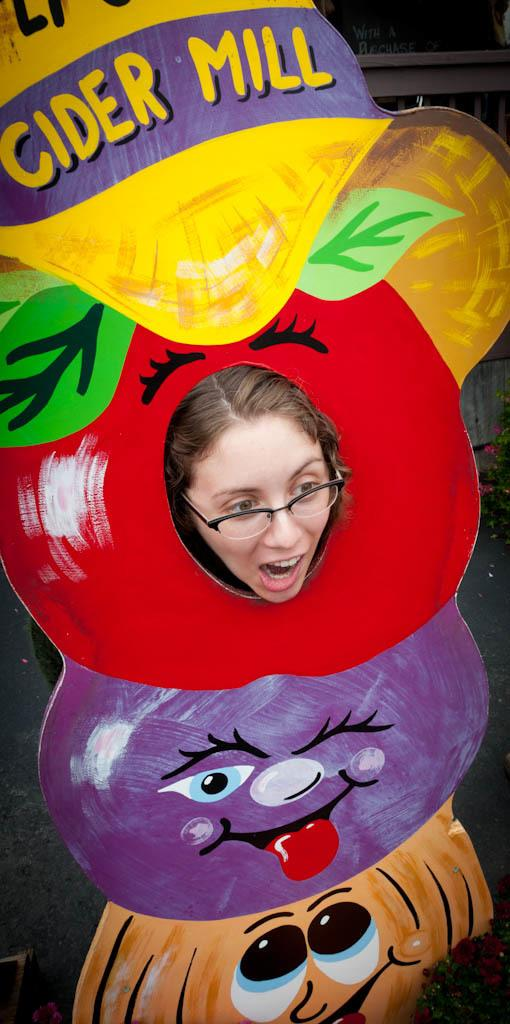What is the main subject of the image? The main subject of the image is a woman's head. What can be seen on the woman's face? The woman is wearing spectacles. What is the appearance of the board in the image? The board has red, purple, and cream colors, and it also has yellow color on it. Can you tell me how many cribs are visible in the image? There are no cribs present in the image. What type of wire is used to hold the pan in the image? There is no wire or pan present in the image. 